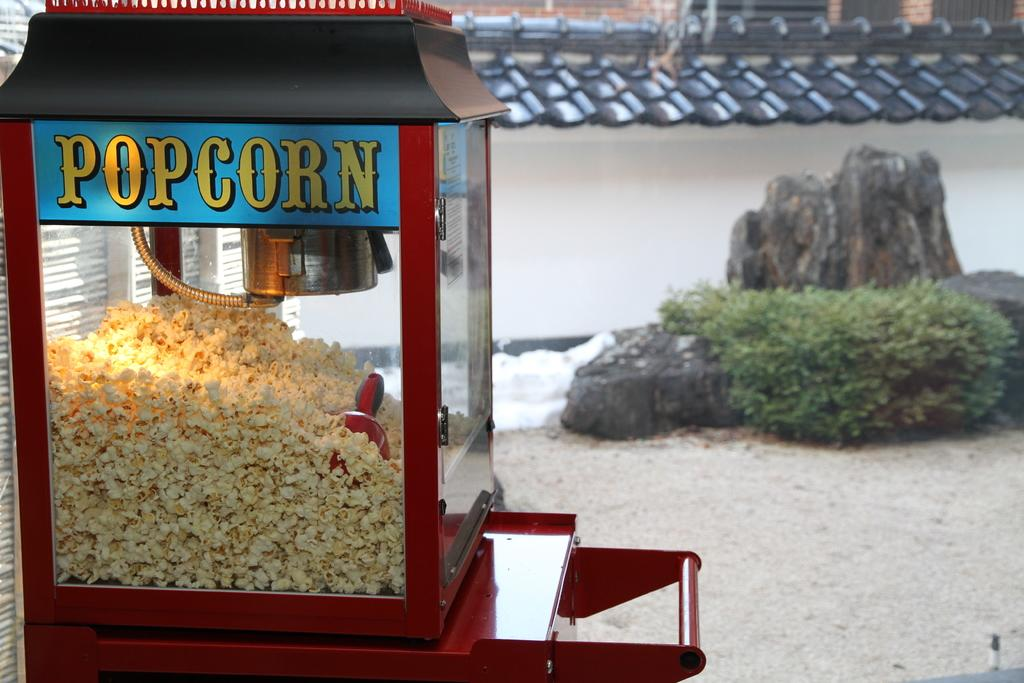<image>
Summarize the visual content of the image. A large popcorn machine is sitting to the side of a rock and bush 